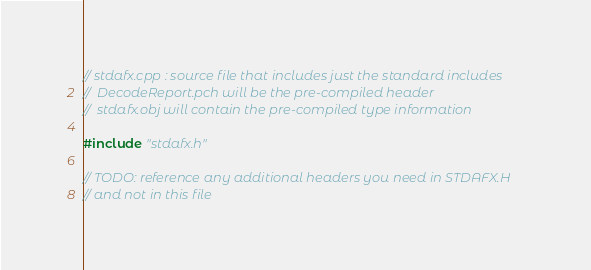<code> <loc_0><loc_0><loc_500><loc_500><_C++_>// stdafx.cpp : source file that includes just the standard includes
//	DecodeReport.pch will be the pre-compiled header
//	stdafx.obj will contain the pre-compiled type information

#include "stdafx.h"

// TODO: reference any additional headers you need in STDAFX.H
// and not in this file
</code> 